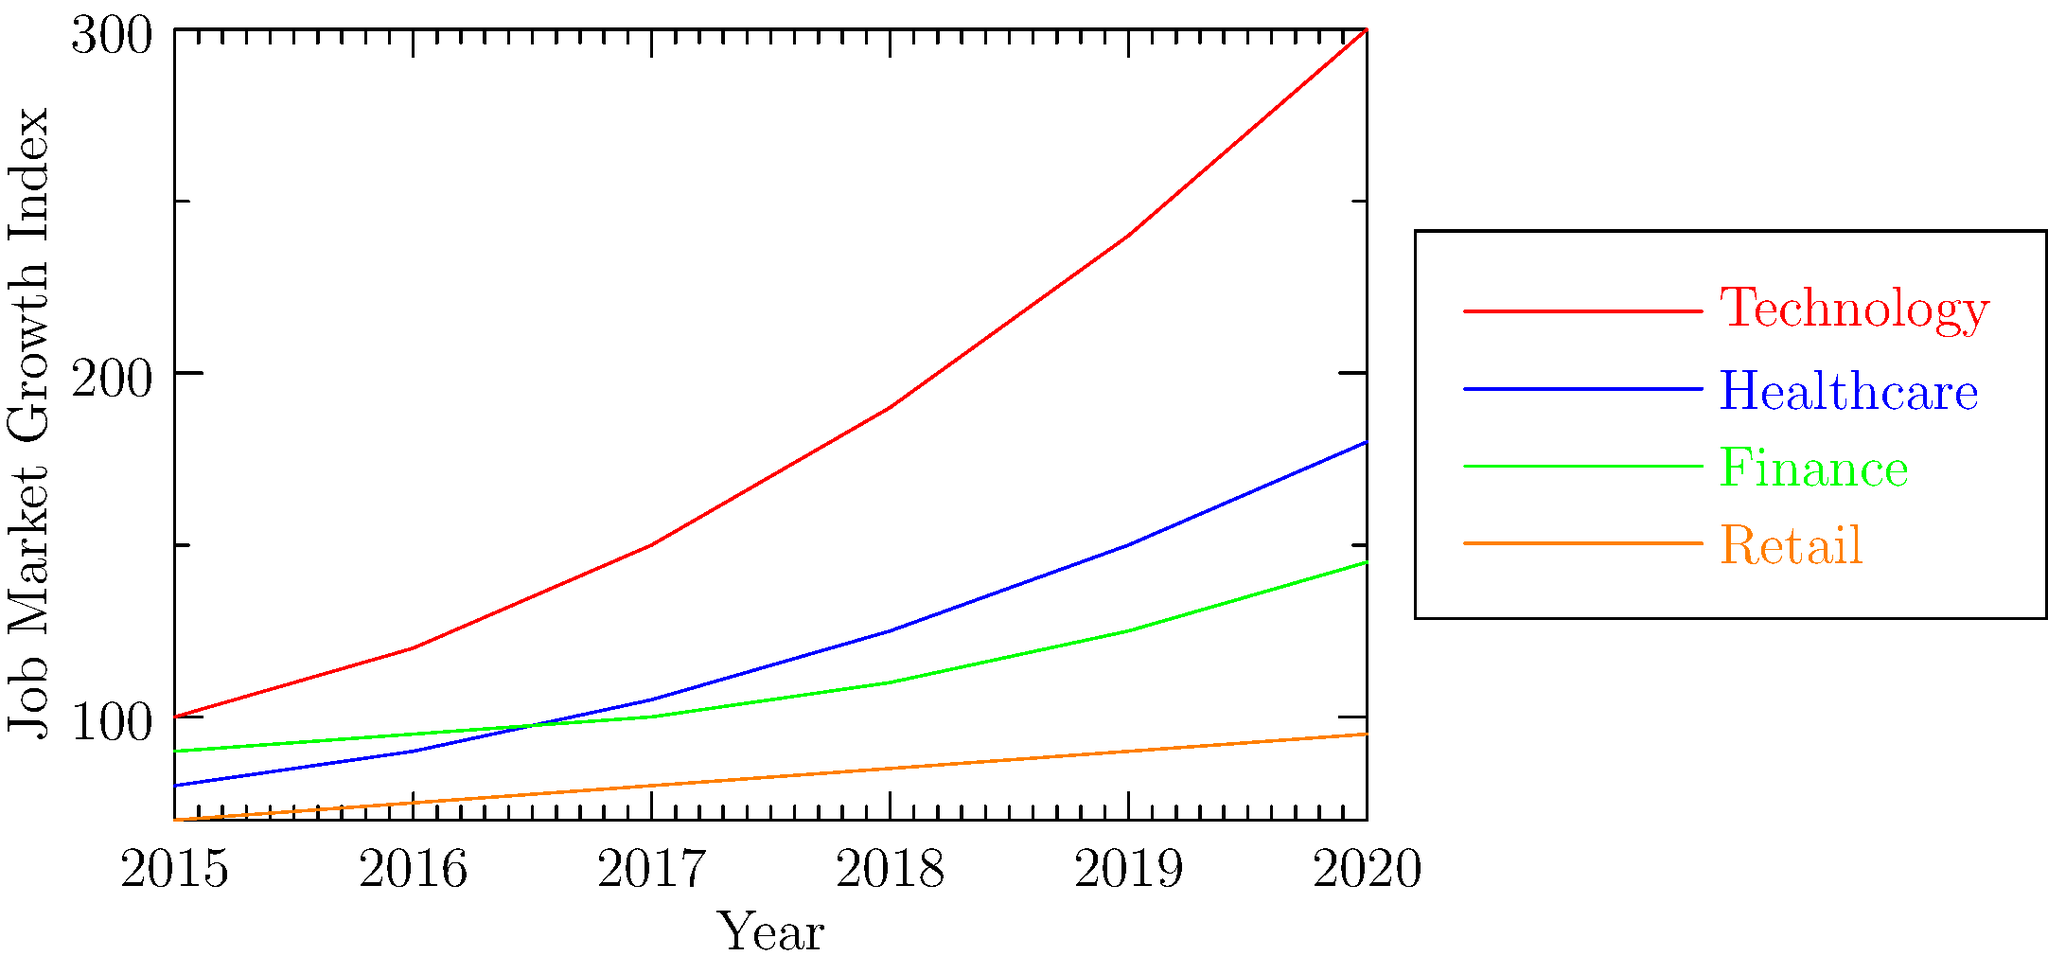As a headhunter, you're analyzing job market trends to identify high-growth sectors for potential placements. Based on the line graph showing job market growth across various sectors from 2015 to 2020, which sector demonstrates the highest growth rate and would likely offer the most opportunities for placing candidates in key positions? To determine the sector with the highest growth rate, we need to analyze the slope of each line, as steeper slopes indicate faster growth:

1. Technology (red line):
   - Starts at 100 in 2015 and reaches 300 in 2020
   - Growth: (300 - 100) / 100 = 200% over 5 years
   - Average annual growth rate: 200% / 5 = 40% per year

2. Healthcare (blue line):
   - Starts at 80 in 2015 and reaches 180 in 2020
   - Growth: (180 - 80) / 80 = 125% over 5 years
   - Average annual growth rate: 125% / 5 = 25% per year

3. Finance (green line):
   - Starts at 90 in 2015 and reaches 145 in 2020
   - Growth: (145 - 90) / 90 ≈ 61% over 5 years
   - Average annual growth rate: 61% / 5 ≈ 12.2% per year

4. Retail (orange line):
   - Starts at 70 in 2015 and reaches 95 in 2020
   - Growth: (95 - 70) / 70 ≈ 36% over 5 years
   - Average annual growth rate: 36% / 5 ≈ 7.2% per year

The technology sector shows the steepest slope and highest growth rate, indicating it would likely offer the most opportunities for placing candidates in key positions.
Answer: Technology sector 